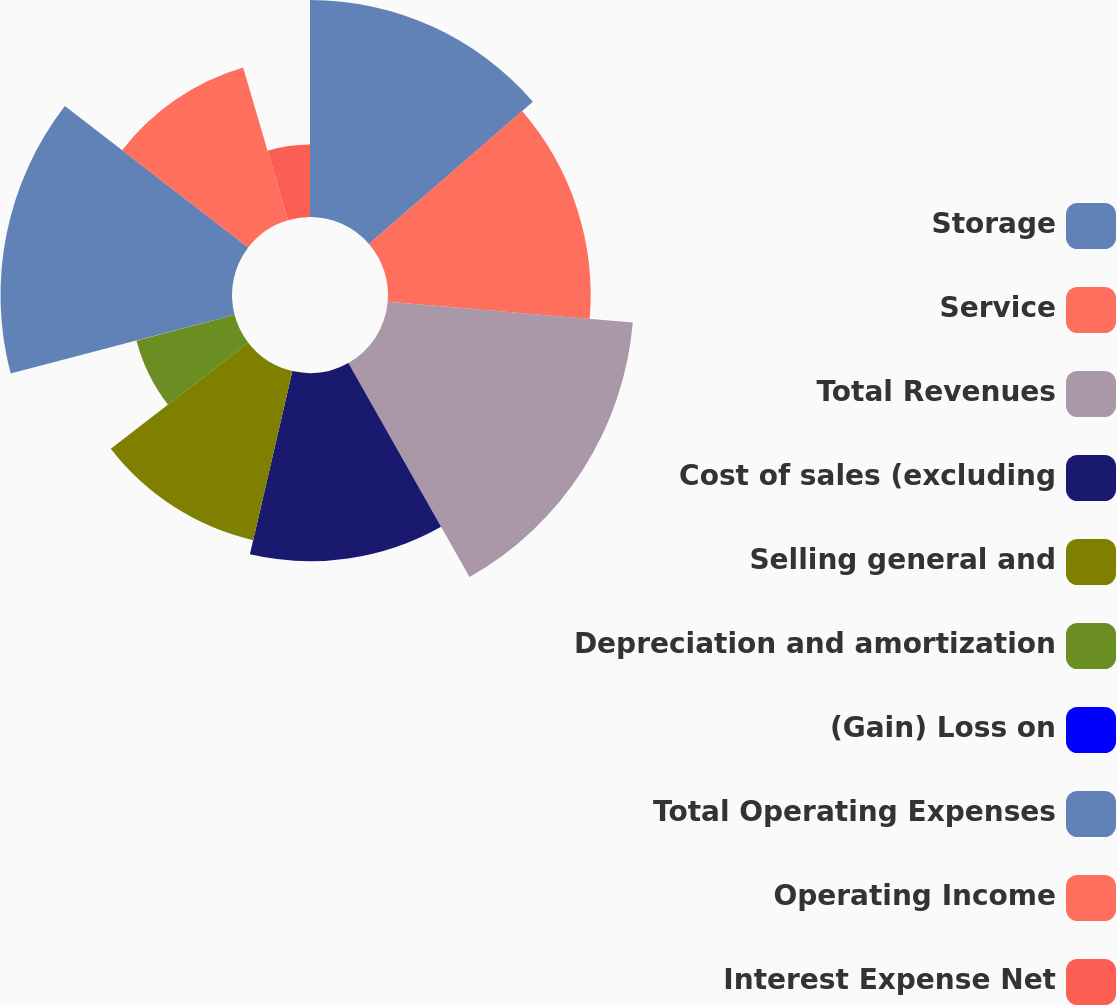<chart> <loc_0><loc_0><loc_500><loc_500><pie_chart><fcel>Storage<fcel>Service<fcel>Total Revenues<fcel>Cost of sales (excluding<fcel>Selling general and<fcel>Depreciation and amortization<fcel>(Gain) Loss on<fcel>Total Operating Expenses<fcel>Operating Income<fcel>Interest Expense Net<nl><fcel>13.63%<fcel>12.73%<fcel>15.45%<fcel>11.82%<fcel>10.91%<fcel>6.37%<fcel>0.01%<fcel>14.54%<fcel>10.0%<fcel>4.55%<nl></chart> 